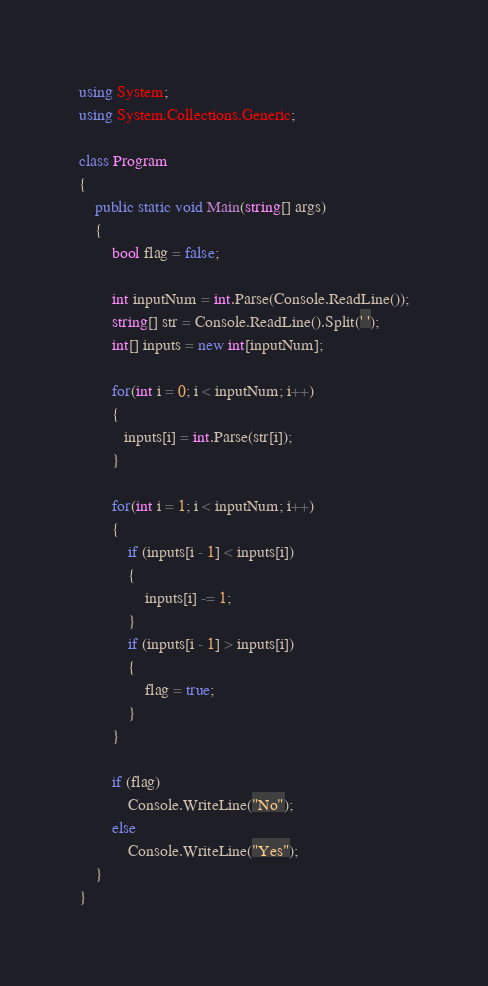<code> <loc_0><loc_0><loc_500><loc_500><_C#_>using System;
using System.Collections.Generic;

class Program
{
    public static void Main(string[] args)
    {
        bool flag = false;

        int inputNum = int.Parse(Console.ReadLine());
        string[] str = Console.ReadLine().Split(' ');
        int[] inputs = new int[inputNum];

        for(int i = 0; i < inputNum; i++)
        {
           inputs[i] = int.Parse(str[i]);
        }

        for(int i = 1; i < inputNum; i++)
        {
            if (inputs[i - 1] < inputs[i])
            {
                inputs[i] -= 1;
            }
            if (inputs[i - 1] > inputs[i])
            {
                flag = true;
            }
        }

        if (flag)
            Console.WriteLine("No");
        else
            Console.WriteLine("Yes");
    }
}
</code> 